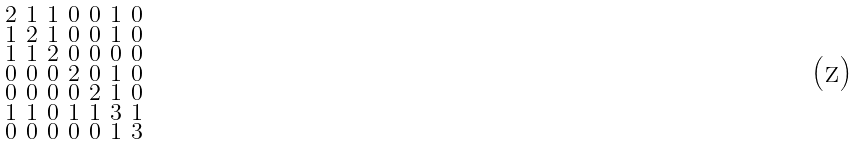Convert formula to latex. <formula><loc_0><loc_0><loc_500><loc_500>\begin{smallmatrix} 2 & 1 & 1 & 0 & 0 & 1 & 0 \\ 1 & 2 & 1 & 0 & 0 & 1 & 0 \\ 1 & 1 & 2 & 0 & 0 & 0 & 0 \\ 0 & 0 & 0 & 2 & 0 & 1 & 0 \\ 0 & 0 & 0 & 0 & 2 & 1 & 0 \\ 1 & 1 & 0 & 1 & 1 & 3 & 1 \\ 0 & 0 & 0 & 0 & 0 & 1 & 3 \end{smallmatrix}</formula> 